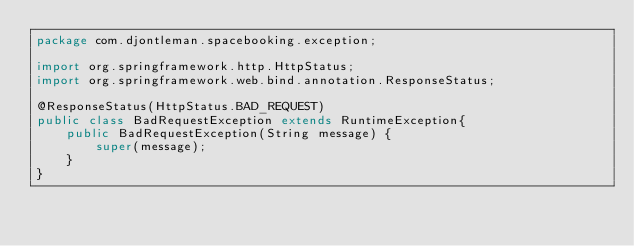Convert code to text. <code><loc_0><loc_0><loc_500><loc_500><_Java_>package com.djontleman.spacebooking.exception;

import org.springframework.http.HttpStatus;
import org.springframework.web.bind.annotation.ResponseStatus;

@ResponseStatus(HttpStatus.BAD_REQUEST)
public class BadRequestException extends RuntimeException{
    public BadRequestException(String message) {
        super(message);
    }
}
</code> 